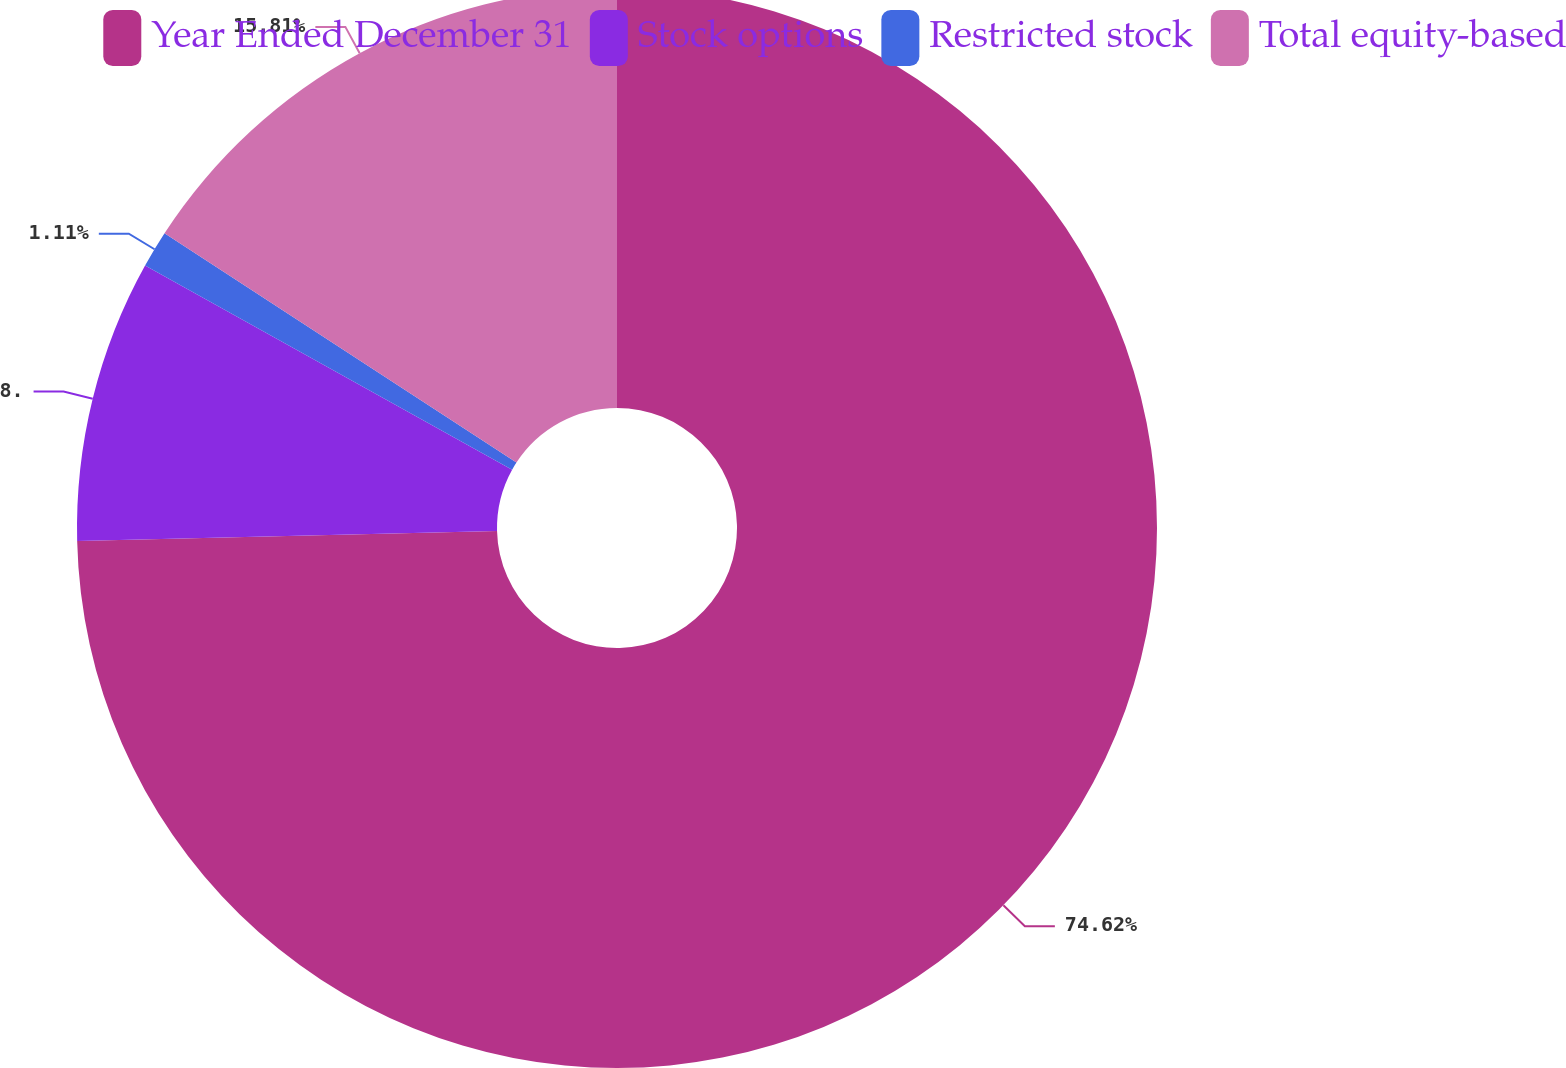Convert chart to OTSL. <chart><loc_0><loc_0><loc_500><loc_500><pie_chart><fcel>Year Ended December 31<fcel>Stock options<fcel>Restricted stock<fcel>Total equity-based<nl><fcel>74.61%<fcel>8.46%<fcel>1.11%<fcel>15.81%<nl></chart> 